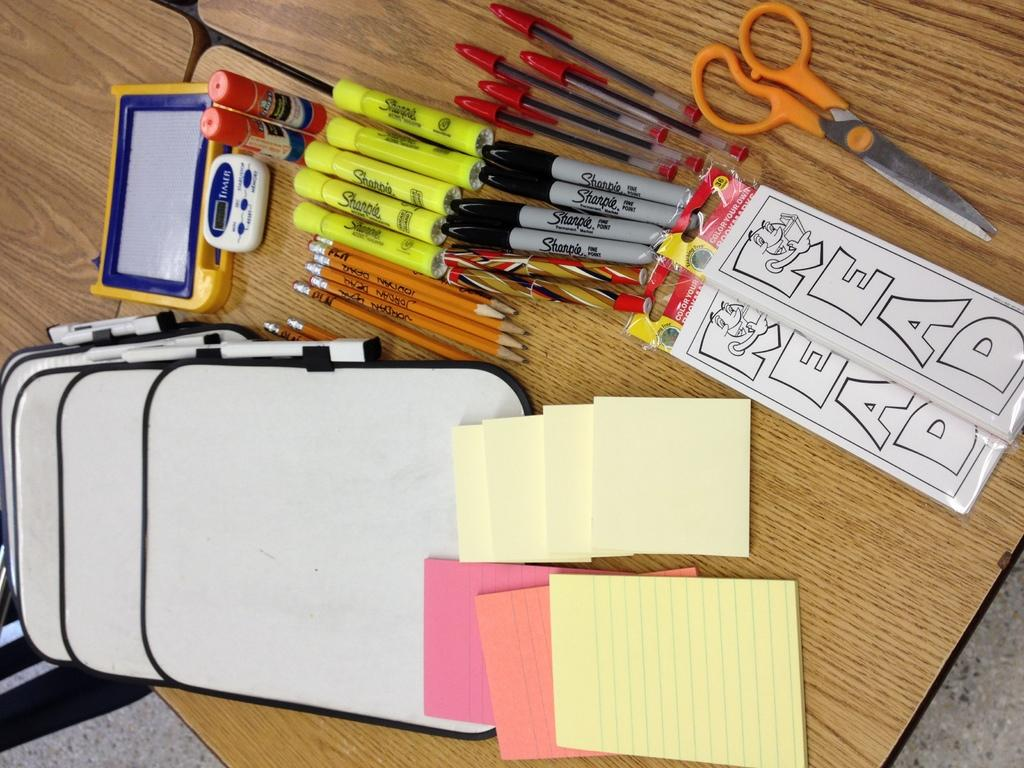<image>
Provide a brief description of the given image. Various school supplies with the word READ on one supply. 